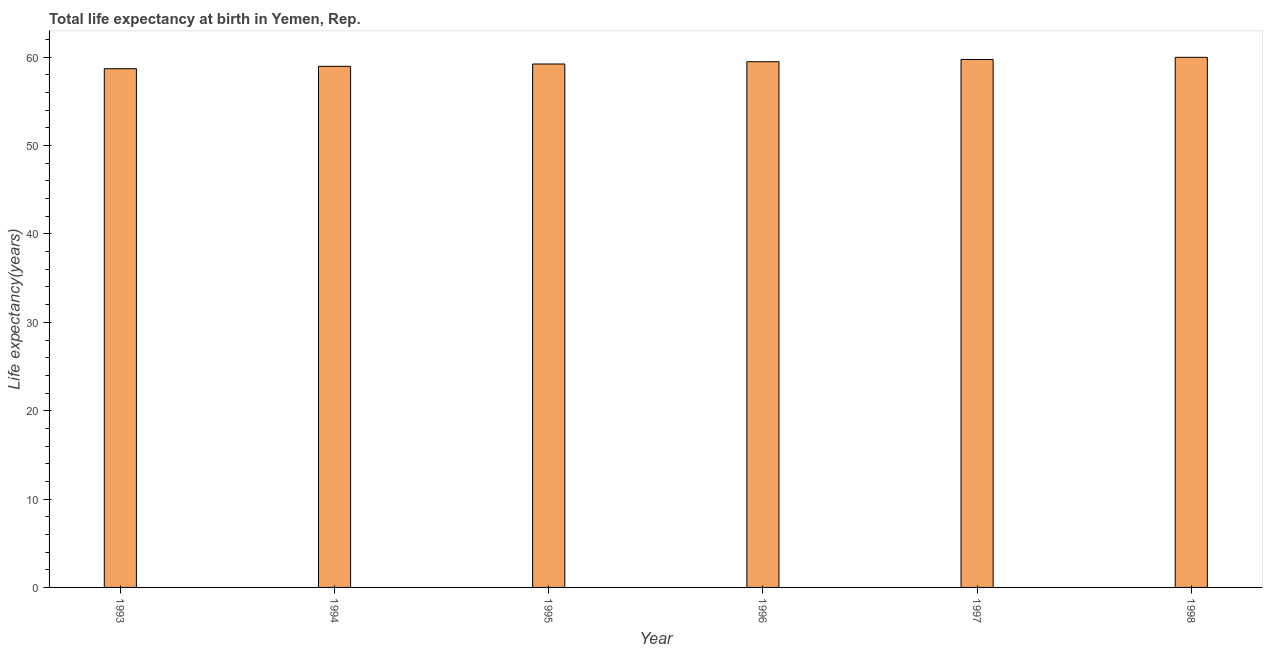Does the graph contain any zero values?
Ensure brevity in your answer.  No. Does the graph contain grids?
Offer a terse response. No. What is the title of the graph?
Provide a succinct answer. Total life expectancy at birth in Yemen, Rep. What is the label or title of the Y-axis?
Ensure brevity in your answer.  Life expectancy(years). What is the life expectancy at birth in 1994?
Your answer should be compact. 58.97. Across all years, what is the maximum life expectancy at birth?
Offer a very short reply. 59.99. Across all years, what is the minimum life expectancy at birth?
Give a very brief answer. 58.7. What is the sum of the life expectancy at birth?
Keep it short and to the point. 356.15. What is the difference between the life expectancy at birth in 1996 and 1998?
Keep it short and to the point. -0.49. What is the average life expectancy at birth per year?
Ensure brevity in your answer.  59.36. What is the median life expectancy at birth?
Offer a terse response. 59.37. In how many years, is the life expectancy at birth greater than 18 years?
Ensure brevity in your answer.  6. Do a majority of the years between 1998 and 1994 (inclusive) have life expectancy at birth greater than 46 years?
Provide a short and direct response. Yes. What is the ratio of the life expectancy at birth in 1995 to that in 1998?
Offer a very short reply. 0.99. Is the difference between the life expectancy at birth in 1996 and 1997 greater than the difference between any two years?
Your answer should be compact. No. What is the difference between the highest and the second highest life expectancy at birth?
Make the answer very short. 0.24. Is the sum of the life expectancy at birth in 1995 and 1996 greater than the maximum life expectancy at birth across all years?
Your answer should be very brief. Yes. What is the difference between the highest and the lowest life expectancy at birth?
Your response must be concise. 1.29. Are all the bars in the graph horizontal?
Your response must be concise. No. What is the Life expectancy(years) in 1993?
Ensure brevity in your answer.  58.7. What is the Life expectancy(years) in 1994?
Your response must be concise. 58.97. What is the Life expectancy(years) of 1995?
Offer a very short reply. 59.24. What is the Life expectancy(years) of 1996?
Provide a succinct answer. 59.5. What is the Life expectancy(years) of 1997?
Your response must be concise. 59.75. What is the Life expectancy(years) in 1998?
Provide a succinct answer. 59.99. What is the difference between the Life expectancy(years) in 1993 and 1994?
Make the answer very short. -0.27. What is the difference between the Life expectancy(years) in 1993 and 1995?
Ensure brevity in your answer.  -0.53. What is the difference between the Life expectancy(years) in 1993 and 1996?
Ensure brevity in your answer.  -0.79. What is the difference between the Life expectancy(years) in 1993 and 1997?
Your answer should be compact. -1.05. What is the difference between the Life expectancy(years) in 1993 and 1998?
Give a very brief answer. -1.29. What is the difference between the Life expectancy(years) in 1994 and 1995?
Keep it short and to the point. -0.26. What is the difference between the Life expectancy(years) in 1994 and 1996?
Your answer should be very brief. -0.52. What is the difference between the Life expectancy(years) in 1994 and 1997?
Ensure brevity in your answer.  -0.78. What is the difference between the Life expectancy(years) in 1994 and 1998?
Make the answer very short. -1.02. What is the difference between the Life expectancy(years) in 1995 and 1996?
Make the answer very short. -0.26. What is the difference between the Life expectancy(years) in 1995 and 1997?
Provide a succinct answer. -0.51. What is the difference between the Life expectancy(years) in 1995 and 1998?
Keep it short and to the point. -0.75. What is the difference between the Life expectancy(years) in 1996 and 1997?
Offer a terse response. -0.25. What is the difference between the Life expectancy(years) in 1996 and 1998?
Keep it short and to the point. -0.5. What is the difference between the Life expectancy(years) in 1997 and 1998?
Ensure brevity in your answer.  -0.24. What is the ratio of the Life expectancy(years) in 1993 to that in 1994?
Keep it short and to the point. 0.99. What is the ratio of the Life expectancy(years) in 1993 to that in 1996?
Make the answer very short. 0.99. What is the ratio of the Life expectancy(years) in 1993 to that in 1997?
Provide a succinct answer. 0.98. What is the ratio of the Life expectancy(years) in 1994 to that in 1995?
Provide a short and direct response. 1. What is the ratio of the Life expectancy(years) in 1994 to that in 1996?
Offer a terse response. 0.99. What is the ratio of the Life expectancy(years) in 1994 to that in 1997?
Keep it short and to the point. 0.99. What is the ratio of the Life expectancy(years) in 1995 to that in 1996?
Give a very brief answer. 1. What is the ratio of the Life expectancy(years) in 1995 to that in 1998?
Make the answer very short. 0.99. 